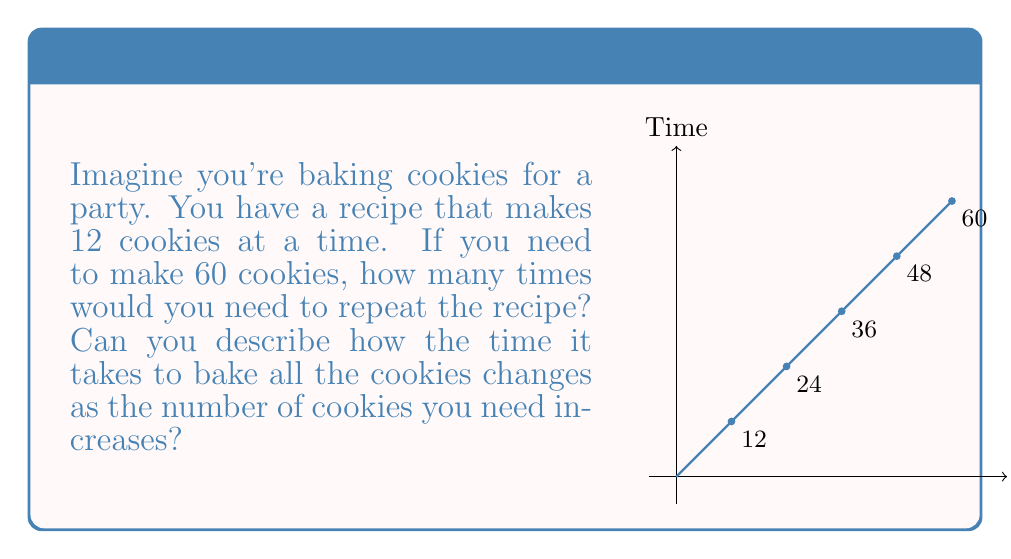Give your solution to this math problem. Let's break this down step-by-step:

1) First, we need to calculate how many times we need to repeat the recipe:
   $\frac{60 \text{ cookies}}{12 \text{ cookies per batch}} = 5 \text{ batches}$

2) Now, let's think about how the baking time changes as we increase the number of cookies:

   - For 12 cookies (1 batch), it takes a certain amount of time, let's call it $t$.
   - For 24 cookies (2 batches), it takes $2t$.
   - For 36 cookies (3 batches), it takes $3t$.
   - For 48 cookies (4 batches), it takes $4t$.
   - For 60 cookies (5 batches), it takes $5t$.

3) We can see a pattern forming. The time taken is directly proportional to the number of batches, which is directly proportional to the number of cookies.

4) In computational complexity theory, we call this a linear time complexity. It's often written as $O(n)$, where $n$ is the input size (in this case, the number of cookies).

5) The graph shows this linear relationship. As the number of cookies increases along the x-axis, the time increases at the same rate along the y-axis, forming a straight line.

6) This is different from, say, a quadratic time complexity $O(n^2)$, where doubling the input would quadruple the time, or a constant time complexity $O(1)$, where the time would stay the same regardless of input size.

In everyday terms, this means that if you want to bake twice as many cookies, it will take you twice as long. If you want to bake three times as many cookies, it will take three times as long, and so on.
Answer: Linear time complexity, $O(n)$ 